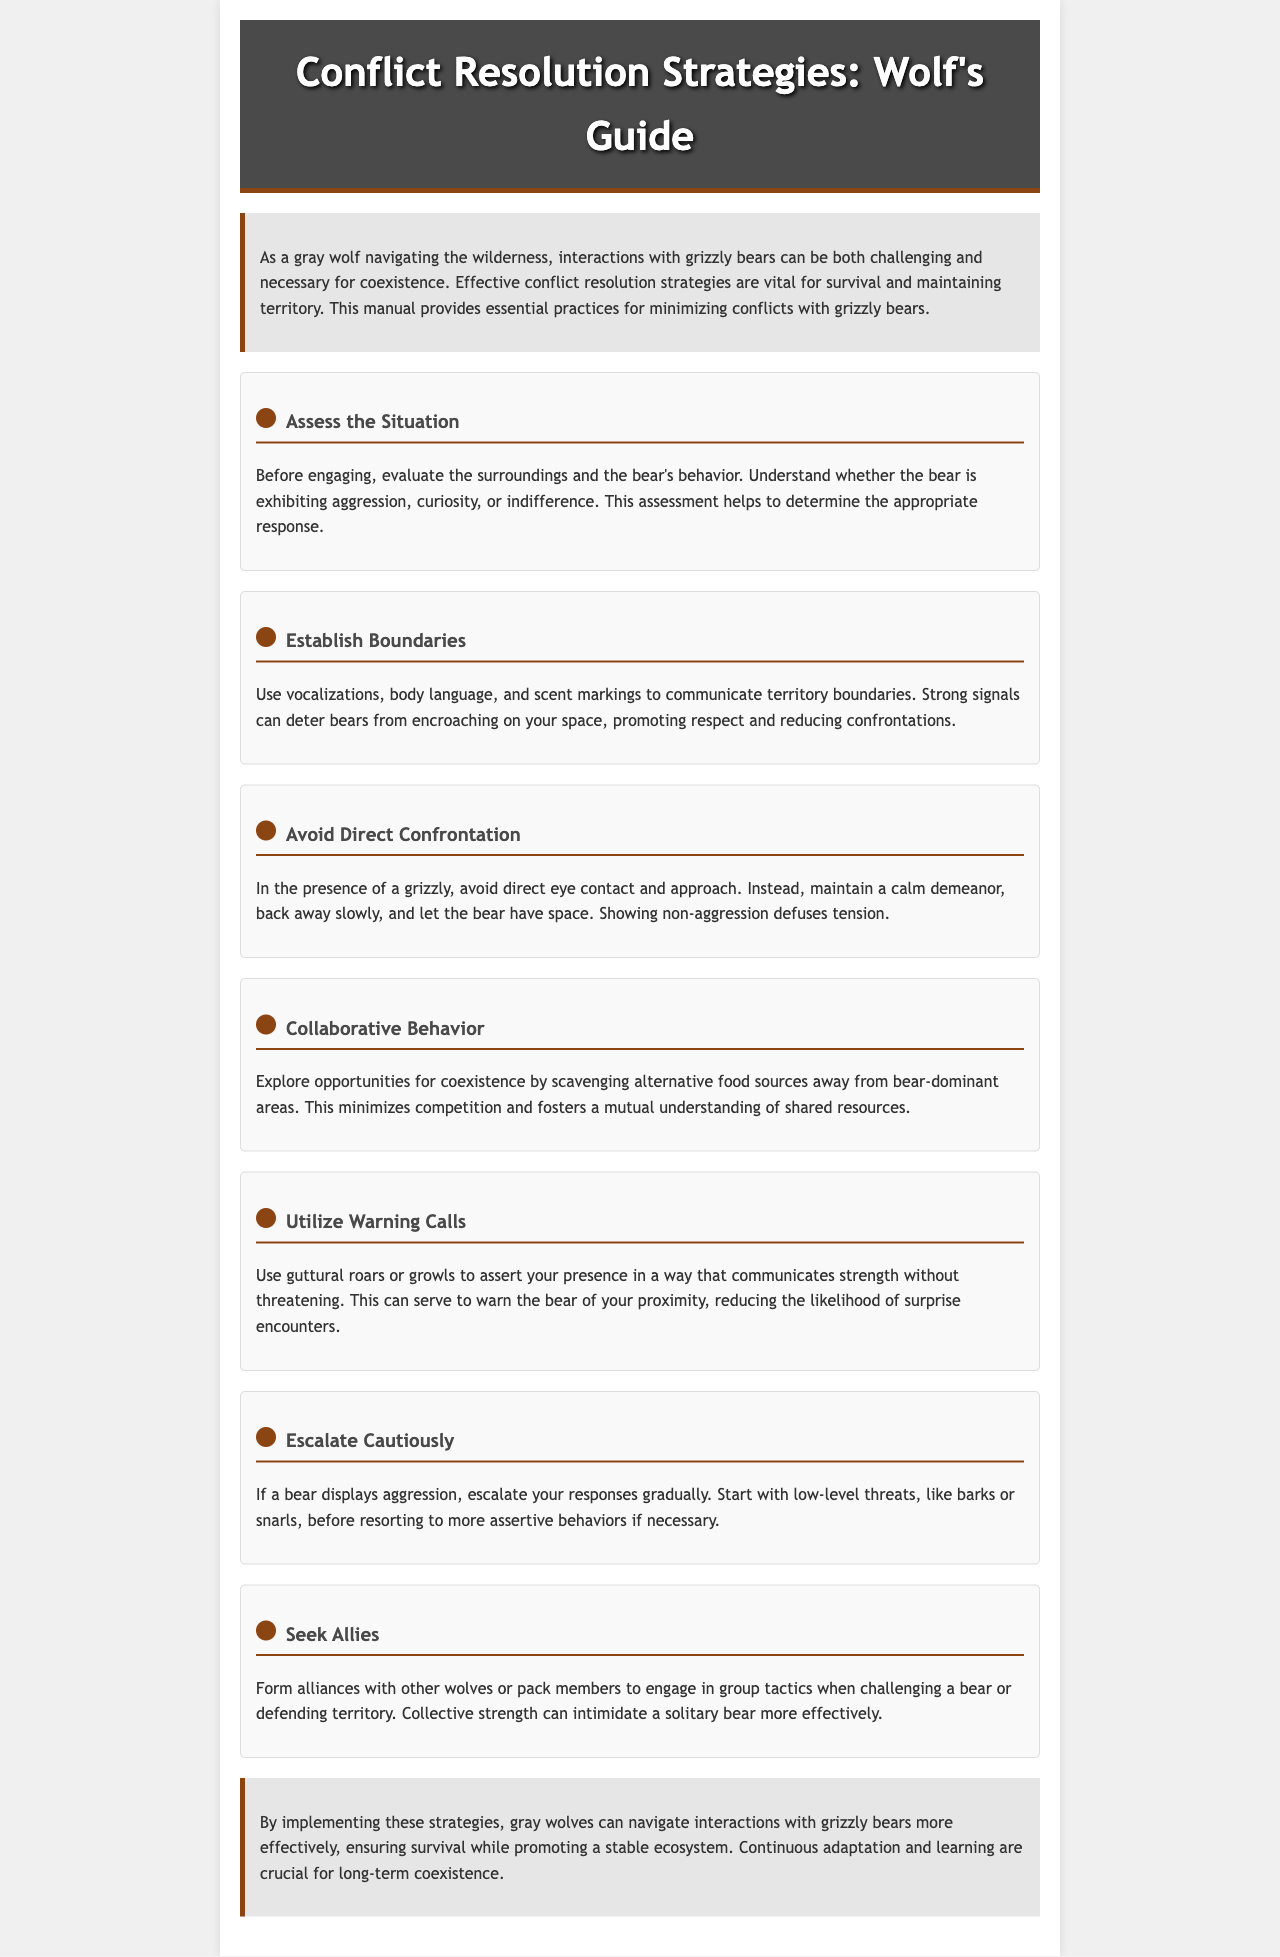what is the title of the manual? The title is mentioned in the header of the document and states the focus on conflict resolution strategies for wolves.
Answer: Conflict Resolution Strategies: Wolf's Guide how many strategies are outlined in the document? The document lists several strategies, each distinguished by its own section. Counting them gives the total.
Answer: Seven what does the strategy "Assess the Situation" emphasize? This strategy focuses on evaluating the environment and the bear's behavior to determine an appropriate response.
Answer: Evaluating surroundings and bear's behavior which strategy suggests using vocalizations? The strategy titled "Establish Boundaries" discusses using vocalizations and body language to communicate territory boundaries.
Answer: Establish Boundaries what is the first step in escalating cautiously? The strategy "Escalate Cautiously" advises starting with low-level threats before more assertive behaviors.
Answer: Low-level threats what behavior should be avoided in the presence of a grizzly? The strategy "Avoid Direct Confrontation" states that one should avoid direct eye contact and approach.
Answer: Direct eye contact what is the main purpose of the manual? The introductory paragraph outlines the manual's goal in providing practices for minimizing conflicts with grizzly bears.
Answer: Minimize conflicts which animal is frequently mentioned as a competitor? The document discusses interactions specifically with one type of competing predator.
Answer: Grizzly bears 